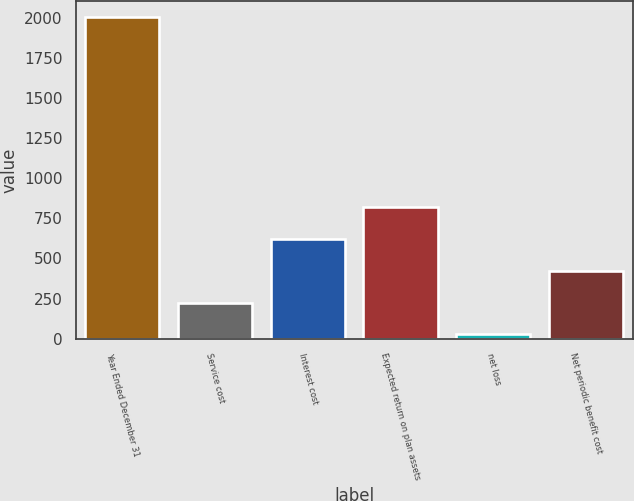<chart> <loc_0><loc_0><loc_500><loc_500><bar_chart><fcel>Year Ended December 31<fcel>Service cost<fcel>Interest cost<fcel>Expected return on plan assets<fcel>net loss<fcel>Net periodic benefit cost<nl><fcel>2006<fcel>224.9<fcel>620.7<fcel>818.6<fcel>27<fcel>422.8<nl></chart> 